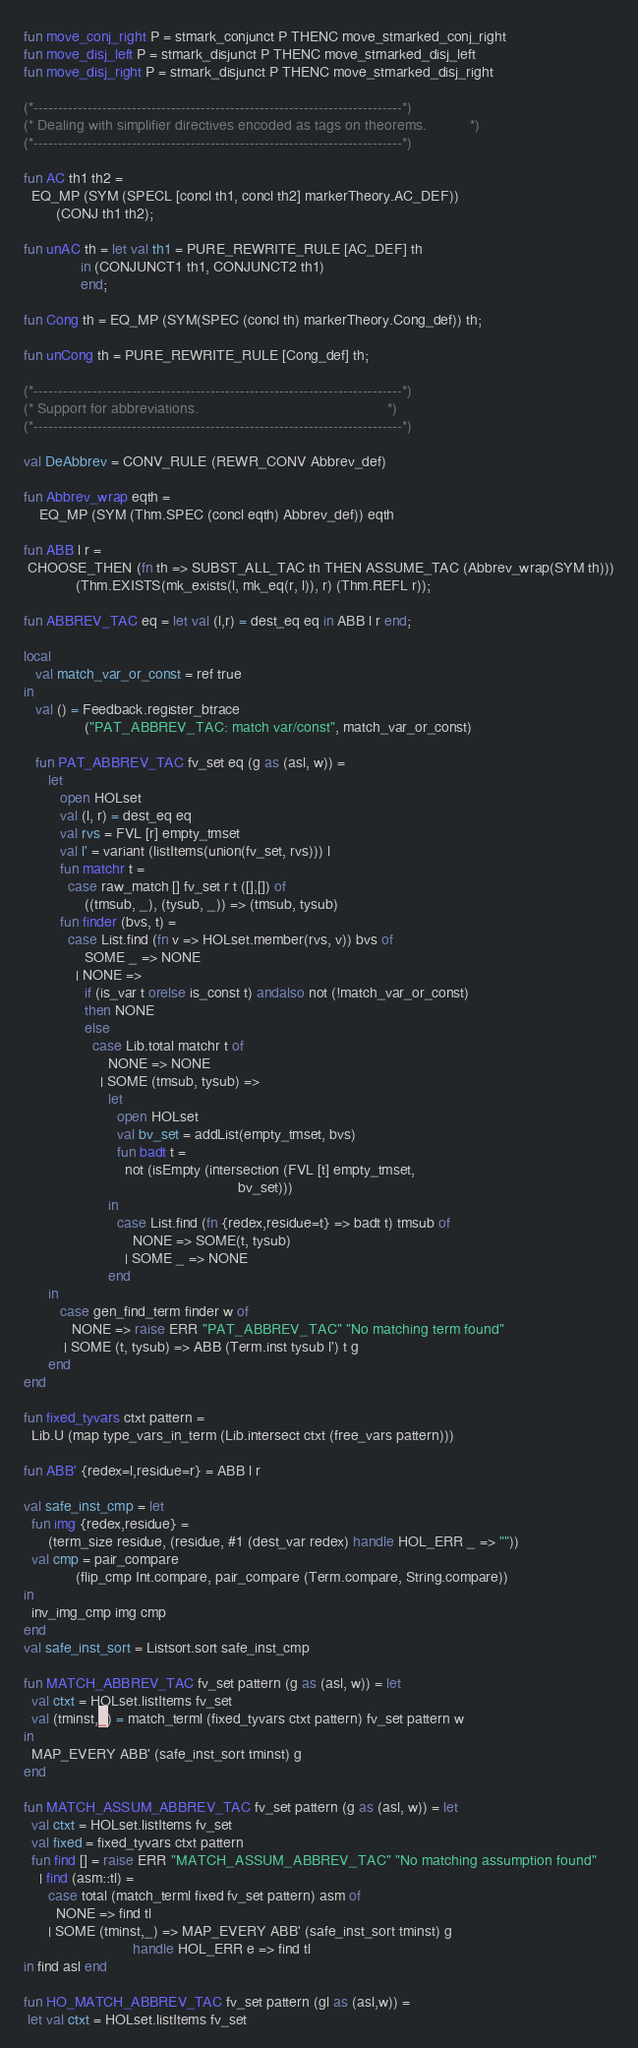Convert code to text. <code><loc_0><loc_0><loc_500><loc_500><_SML_>fun move_conj_right P = stmark_conjunct P THENC move_stmarked_conj_right
fun move_disj_left P = stmark_disjunct P THENC move_stmarked_disj_left
fun move_disj_right P = stmark_disjunct P THENC move_stmarked_disj_right

(*---------------------------------------------------------------------------*)
(* Dealing with simplifier directives encoded as tags on theorems.           *)
(*---------------------------------------------------------------------------*)

fun AC th1 th2 =
  EQ_MP (SYM (SPECL [concl th1, concl th2] markerTheory.AC_DEF))
        (CONJ th1 th2);

fun unAC th = let val th1 = PURE_REWRITE_RULE [AC_DEF] th
              in (CONJUNCT1 th1, CONJUNCT2 th1)
              end;

fun Cong th = EQ_MP (SYM(SPEC (concl th) markerTheory.Cong_def)) th;

fun unCong th = PURE_REWRITE_RULE [Cong_def] th;

(*---------------------------------------------------------------------------*)
(* Support for abbreviations.                                                *)
(*---------------------------------------------------------------------------*)

val DeAbbrev = CONV_RULE (REWR_CONV Abbrev_def)

fun Abbrev_wrap eqth =
    EQ_MP (SYM (Thm.SPEC (concl eqth) Abbrev_def)) eqth

fun ABB l r =
 CHOOSE_THEN (fn th => SUBST_ALL_TAC th THEN ASSUME_TAC (Abbrev_wrap(SYM th)))
             (Thm.EXISTS(mk_exists(l, mk_eq(r, l)), r) (Thm.REFL r));

fun ABBREV_TAC eq = let val (l,r) = dest_eq eq in ABB l r end;

local
   val match_var_or_const = ref true
in
   val () = Feedback.register_btrace
               ("PAT_ABBREV_TAC: match var/const", match_var_or_const)

   fun PAT_ABBREV_TAC fv_set eq (g as (asl, w)) =
      let
         open HOLset
         val (l, r) = dest_eq eq
         val rvs = FVL [r] empty_tmset
         val l' = variant (listItems(union(fv_set, rvs))) l
         fun matchr t =
           case raw_match [] fv_set r t ([],[]) of
               ((tmsub, _), (tysub, _)) => (tmsub, tysub)
         fun finder (bvs, t) =
           case List.find (fn v => HOLset.member(rvs, v)) bvs of
               SOME _ => NONE
             | NONE =>
               if (is_var t orelse is_const t) andalso not (!match_var_or_const)
               then NONE
               else
                 case Lib.total matchr t of
                     NONE => NONE
                   | SOME (tmsub, tysub) =>
                     let
                       open HOLset
                       val bv_set = addList(empty_tmset, bvs)
                       fun badt t =
                         not (isEmpty (intersection (FVL [t] empty_tmset,
                                                     bv_set)))
                     in
                       case List.find (fn {redex,residue=t} => badt t) tmsub of
                           NONE => SOME(t, tysub)
                         | SOME _ => NONE
                     end
      in
         case gen_find_term finder w of
            NONE => raise ERR "PAT_ABBREV_TAC" "No matching term found"
          | SOME (t, tysub) => ABB (Term.inst tysub l') t g
      end
end

fun fixed_tyvars ctxt pattern =
  Lib.U (map type_vars_in_term (Lib.intersect ctxt (free_vars pattern)))

fun ABB' {redex=l,residue=r} = ABB l r

val safe_inst_cmp = let
  fun img {redex,residue} =
      (term_size residue, (residue, #1 (dest_var redex) handle HOL_ERR _ => ""))
  val cmp = pair_compare
             (flip_cmp Int.compare, pair_compare (Term.compare, String.compare))
in
  inv_img_cmp img cmp
end
val safe_inst_sort = Listsort.sort safe_inst_cmp

fun MATCH_ABBREV_TAC fv_set pattern (g as (asl, w)) = let
  val ctxt = HOLset.listItems fv_set
  val (tminst,_) = match_terml (fixed_tyvars ctxt pattern) fv_set pattern w
in
  MAP_EVERY ABB' (safe_inst_sort tminst) g
end

fun MATCH_ASSUM_ABBREV_TAC fv_set pattern (g as (asl, w)) = let
  val ctxt = HOLset.listItems fv_set
  val fixed = fixed_tyvars ctxt pattern
  fun find [] = raise ERR "MATCH_ASSUM_ABBREV_TAC" "No matching assumption found"
    | find (asm::tl) =
      case total (match_terml fixed fv_set pattern) asm of
        NONE => find tl
      | SOME (tminst,_) => MAP_EVERY ABB' (safe_inst_sort tminst) g
                           handle HOL_ERR e => find tl
in find asl end

fun HO_MATCH_ABBREV_TAC fv_set pattern (gl as (asl,w)) =
 let val ctxt = HOLset.listItems fv_set</code> 